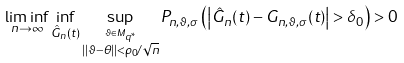Convert formula to latex. <formula><loc_0><loc_0><loc_500><loc_500>\liminf _ { n \rightarrow \infty } \inf _ { \hat { G } _ { n } ( t ) } \sup _ { \overset { \vartheta \in M _ { q ^ { \ast } } } { | | \vartheta - \theta | | < \rho _ { 0 } / \sqrt { n } } } P _ { n , \vartheta , \sigma } \left ( \left | \hat { G } _ { n } ( t ) - G _ { n , \vartheta , \sigma } ( t ) \right | > \delta _ { 0 } \right ) > 0</formula> 